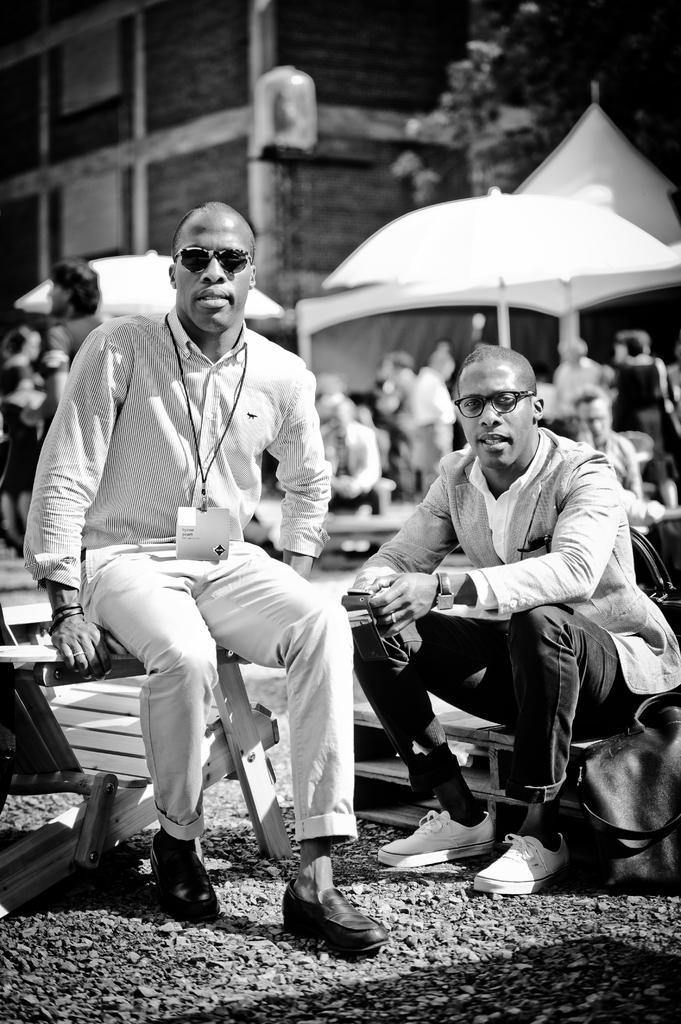Describe this image in one or two sentences. It is a black and white image. In this image we can see two persons wearing glasses and sitting on the benches which are on the ground. In the background we can see the building, tree and also tents and some people. 